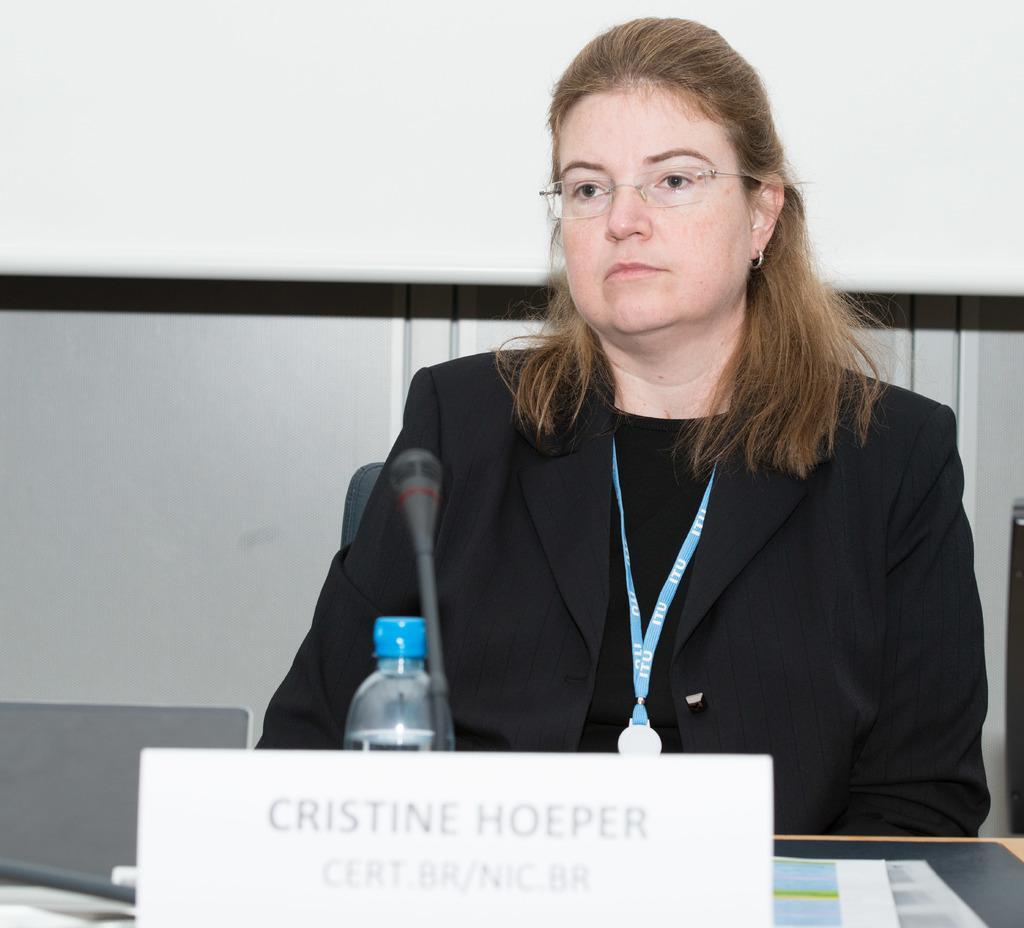Could you give a brief overview of what you see in this image? There is a woman sitting on a chair and she is looking at someone. This is a wooden table where a microphone and a bottle are kept on it. 